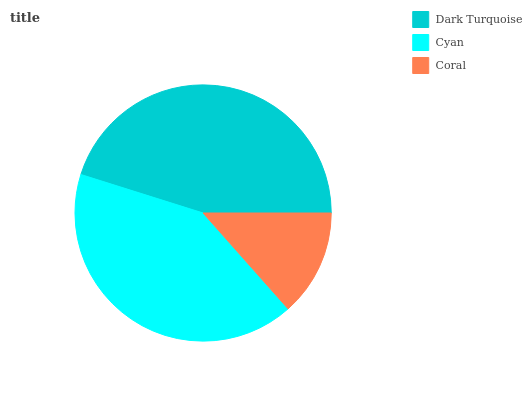Is Coral the minimum?
Answer yes or no. Yes. Is Dark Turquoise the maximum?
Answer yes or no. Yes. Is Cyan the minimum?
Answer yes or no. No. Is Cyan the maximum?
Answer yes or no. No. Is Dark Turquoise greater than Cyan?
Answer yes or no. Yes. Is Cyan less than Dark Turquoise?
Answer yes or no. Yes. Is Cyan greater than Dark Turquoise?
Answer yes or no. No. Is Dark Turquoise less than Cyan?
Answer yes or no. No. Is Cyan the high median?
Answer yes or no. Yes. Is Cyan the low median?
Answer yes or no. Yes. Is Dark Turquoise the high median?
Answer yes or no. No. Is Coral the low median?
Answer yes or no. No. 